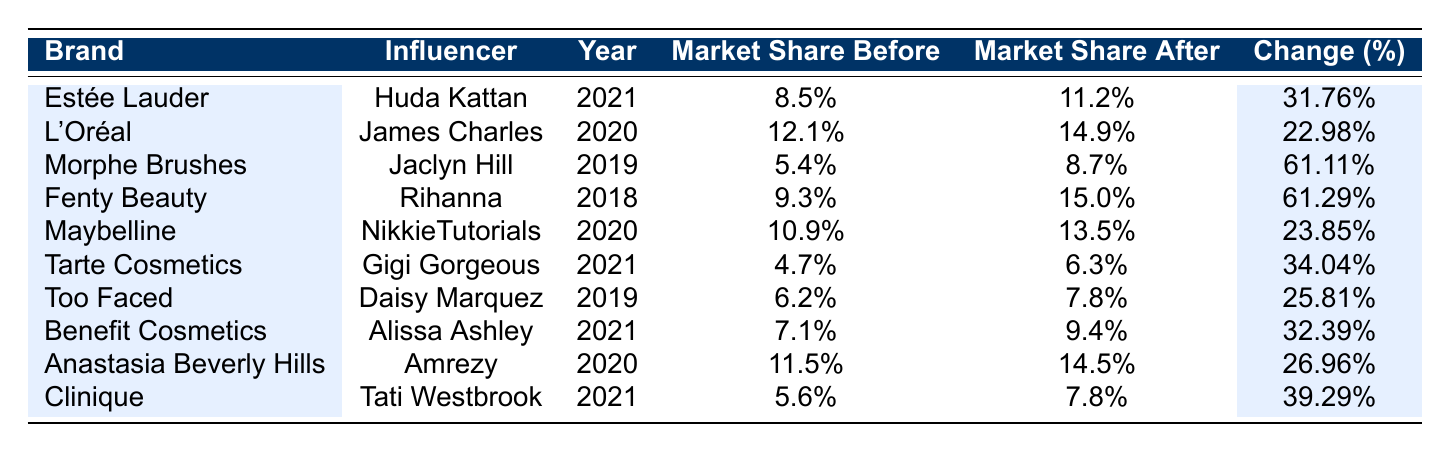What was the market share of Estée Lauder before their collaboration with Huda Kattan? From the table, we can locate the row for Estée Lauder, which states that the market share before the collaboration was 8.5%.
Answer: 8.5% Which brand had the highest percentage increase in market share after an influencer collaboration? Reviewing the "Change (%)" column, Morphe Brushes with Jaclyn Hill shows a change of 61.11%, while Fenty Beauty with Rihanna shows a change of 61.29%. Thus, Fenty Beauty had the highest increase at 61.29%.
Answer: Fenty Beauty Did L'Oréal's market share increase by more than 20% after its collaboration with James Charles? Checking the "Change (%)" for L'Oréal, it shows a change of 22.98%. Since 22.98% is indeed more than 20%, the answer is yes.
Answer: Yes What is the average market share increase percentage for all brands listed in the table? To calculate the average, sum all the "Change (%)" values: 31.76 + 22.98 + 61.11 + 61.29 + 23.85 + 34.04 + 25.81 + 32.39 + 26.96 + 39.29 =  2.9232 and then divide by 10 (the number of entries), resulting in an average of approximately 29.23%.
Answer: 29.23% Which influencer helped Clinique achieve their market share increase, and what was the percentage change? The table indicates that Clinique collaborated with Tati Westbrook, which led to a percentage change of 39.29%.
Answer: Tati Westbrook, 39.29% 